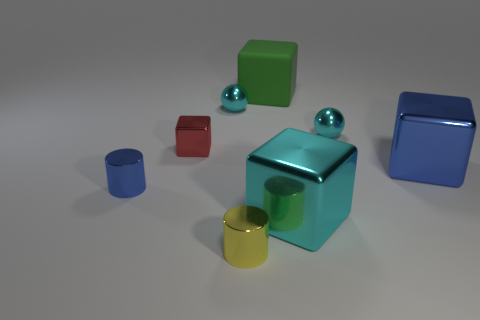The tiny block that is the same material as the large blue block is what color?
Make the answer very short. Red. How many objects are either green rubber cubes or blue metallic cylinders?
Offer a very short reply. 2. The cyan thing that is the same size as the matte block is what shape?
Your answer should be compact. Cube. How many metal objects are in front of the red metal object and right of the large cyan cube?
Ensure brevity in your answer.  1. What is the material of the cyan thing to the left of the small yellow object?
Your answer should be very brief. Metal. What is the size of the red cube that is made of the same material as the tiny blue object?
Offer a very short reply. Small. Is the size of the shiny cube that is behind the large blue metal block the same as the blue metal object that is to the left of the large green matte object?
Provide a short and direct response. Yes. There is a red object that is the same size as the yellow shiny thing; what is it made of?
Offer a very short reply. Metal. What is the cube that is both to the left of the big cyan object and in front of the green matte object made of?
Offer a very short reply. Metal. Is there a big purple matte block?
Offer a very short reply. No. 